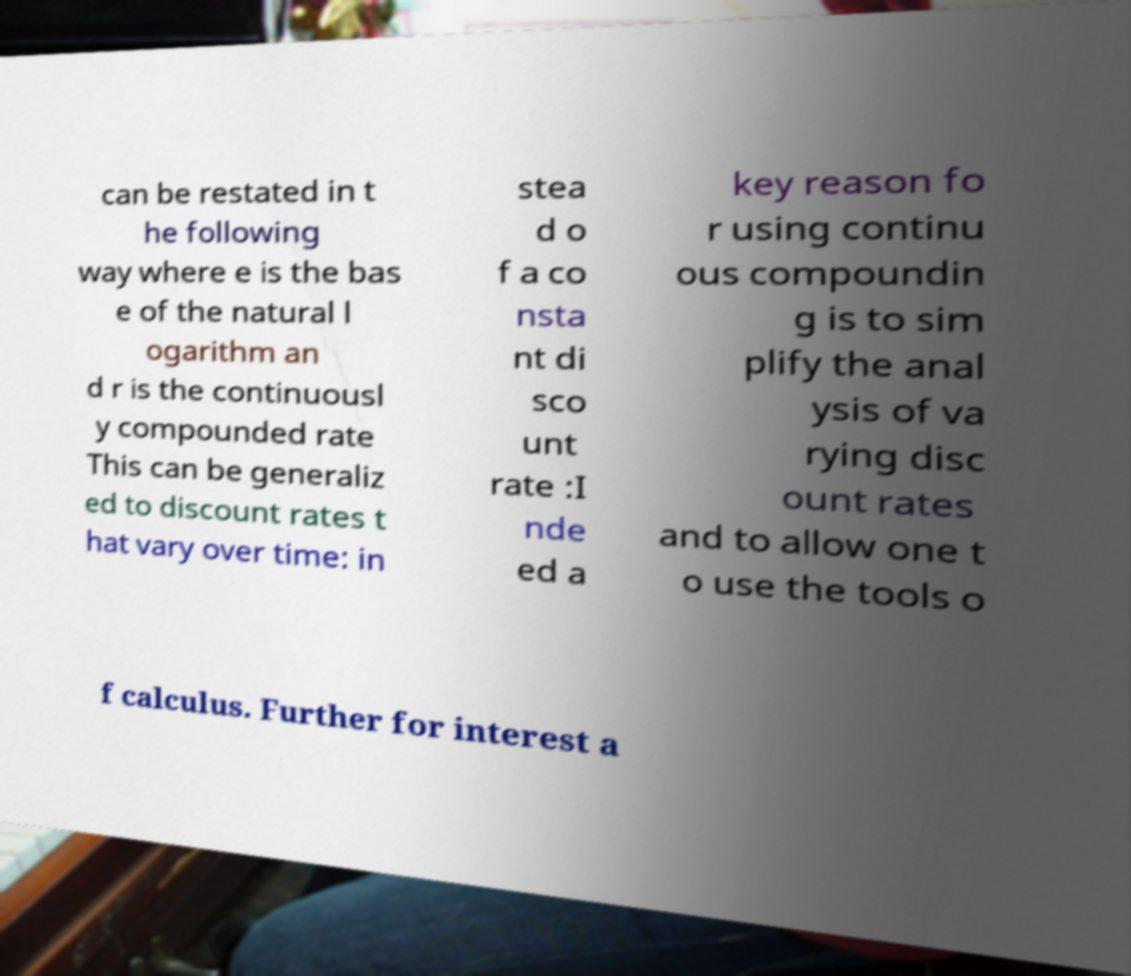For documentation purposes, I need the text within this image transcribed. Could you provide that? can be restated in t he following way where e is the bas e of the natural l ogarithm an d r is the continuousl y compounded rate This can be generaliz ed to discount rates t hat vary over time: in stea d o f a co nsta nt di sco unt rate :I nde ed a key reason fo r using continu ous compoundin g is to sim plify the anal ysis of va rying disc ount rates and to allow one t o use the tools o f calculus. Further for interest a 